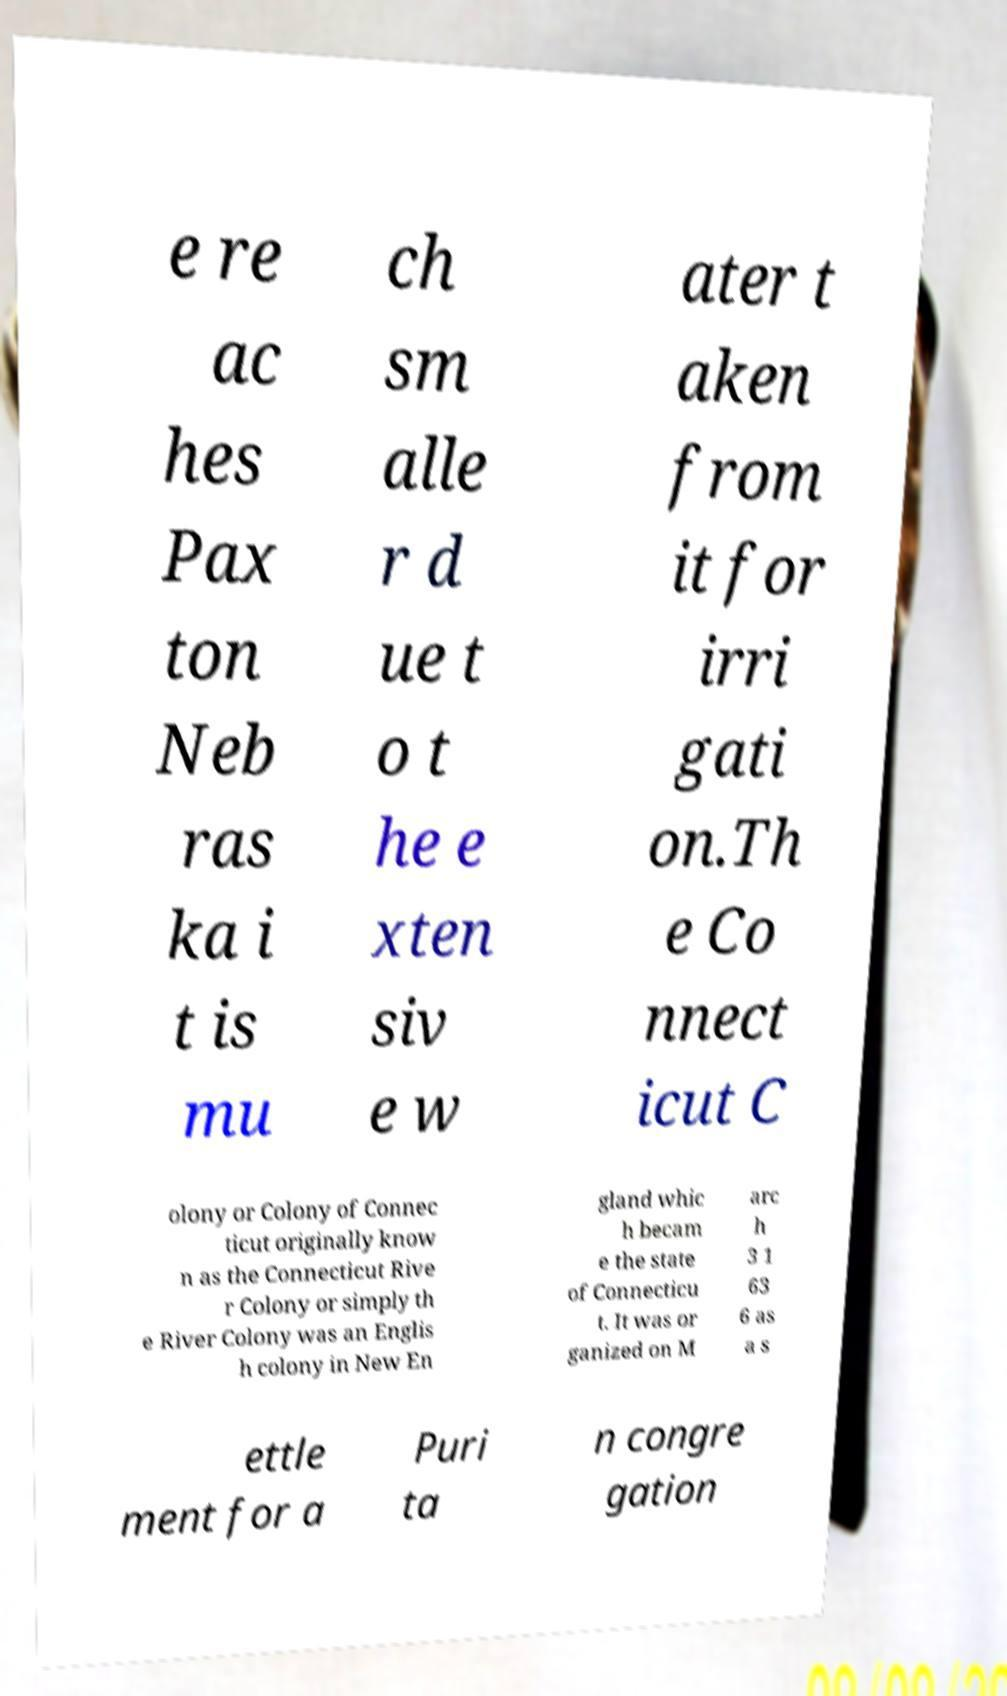Please read and relay the text visible in this image. What does it say? e re ac hes Pax ton Neb ras ka i t is mu ch sm alle r d ue t o t he e xten siv e w ater t aken from it for irri gati on.Th e Co nnect icut C olony or Colony of Connec ticut originally know n as the Connecticut Rive r Colony or simply th e River Colony was an Englis h colony in New En gland whic h becam e the state of Connecticu t. It was or ganized on M arc h 3 1 63 6 as a s ettle ment for a Puri ta n congre gation 